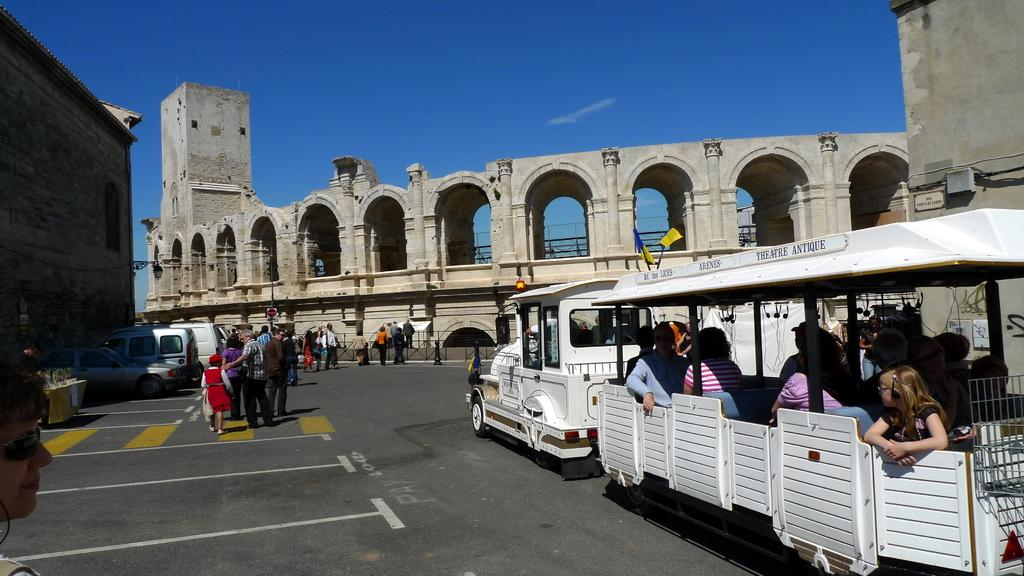What type of structures can be seen in the image? There are buildings in the image. What else can be seen on the ground in the image? There are vehicles on the road in the image. Are there any living beings present in the image? Yes, there are people in the image. Can you describe the location of some people in the image? Some people are inside a vehicle. What is visible in the background of the image? The sky is visible in the background of the image. How many family members are visiting the area in the image? There is no mention of a family or visitors in the image; it only shows buildings, vehicles, people, and the sky. 